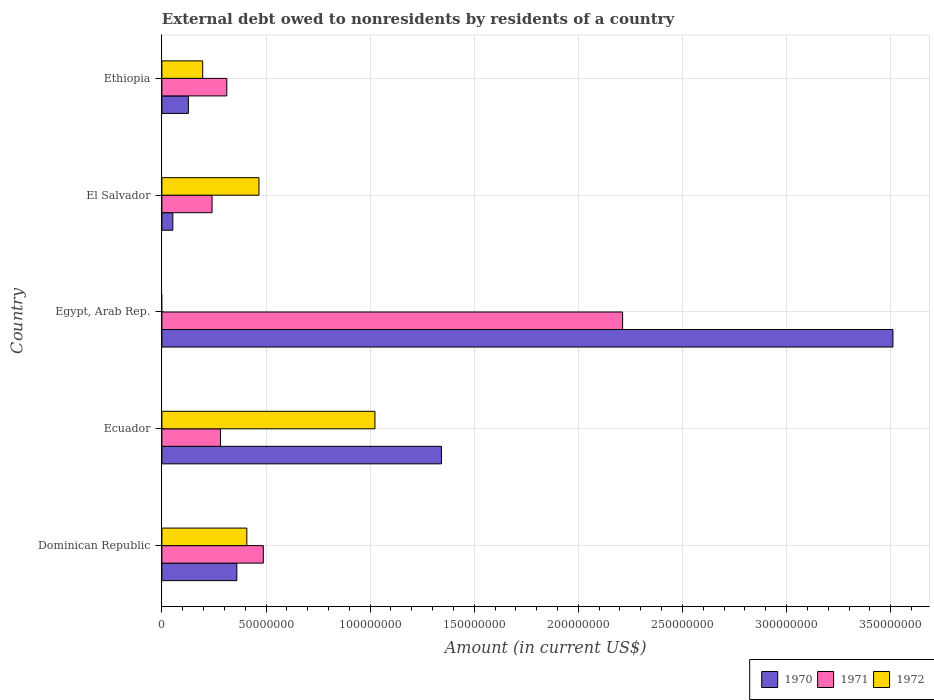Are the number of bars on each tick of the Y-axis equal?
Make the answer very short. No. What is the label of the 2nd group of bars from the top?
Provide a succinct answer. El Salvador. In how many cases, is the number of bars for a given country not equal to the number of legend labels?
Your answer should be very brief. 1. What is the external debt owed by residents in 1972 in Egypt, Arab Rep.?
Keep it short and to the point. 0. Across all countries, what is the maximum external debt owed by residents in 1971?
Your answer should be compact. 2.21e+08. Across all countries, what is the minimum external debt owed by residents in 1971?
Your answer should be very brief. 2.41e+07. In which country was the external debt owed by residents in 1971 maximum?
Your answer should be very brief. Egypt, Arab Rep. What is the total external debt owed by residents in 1970 in the graph?
Give a very brief answer. 5.39e+08. What is the difference between the external debt owed by residents in 1970 in Dominican Republic and that in El Salvador?
Offer a terse response. 3.07e+07. What is the difference between the external debt owed by residents in 1972 in El Salvador and the external debt owed by residents in 1970 in Dominican Republic?
Provide a short and direct response. 1.06e+07. What is the average external debt owed by residents in 1971 per country?
Your response must be concise. 7.07e+07. What is the difference between the external debt owed by residents in 1970 and external debt owed by residents in 1972 in El Salvador?
Provide a short and direct response. -4.14e+07. What is the ratio of the external debt owed by residents in 1972 in Dominican Republic to that in El Salvador?
Give a very brief answer. 0.88. Is the external debt owed by residents in 1970 in Egypt, Arab Rep. less than that in Ethiopia?
Provide a short and direct response. No. What is the difference between the highest and the second highest external debt owed by residents in 1970?
Make the answer very short. 2.17e+08. What is the difference between the highest and the lowest external debt owed by residents in 1972?
Offer a very short reply. 1.02e+08. In how many countries, is the external debt owed by residents in 1971 greater than the average external debt owed by residents in 1971 taken over all countries?
Ensure brevity in your answer.  1. Is the sum of the external debt owed by residents in 1971 in Dominican Republic and El Salvador greater than the maximum external debt owed by residents in 1972 across all countries?
Your answer should be compact. No. Is it the case that in every country, the sum of the external debt owed by residents in 1972 and external debt owed by residents in 1970 is greater than the external debt owed by residents in 1971?
Your answer should be very brief. Yes. How many countries are there in the graph?
Your answer should be very brief. 5. What is the difference between two consecutive major ticks on the X-axis?
Offer a terse response. 5.00e+07. Does the graph contain any zero values?
Provide a short and direct response. Yes. Does the graph contain grids?
Your answer should be compact. Yes. Where does the legend appear in the graph?
Your answer should be compact. Bottom right. What is the title of the graph?
Your answer should be very brief. External debt owed to nonresidents by residents of a country. What is the label or title of the X-axis?
Keep it short and to the point. Amount (in current US$). What is the label or title of the Y-axis?
Provide a succinct answer. Country. What is the Amount (in current US$) in 1970 in Dominican Republic?
Offer a very short reply. 3.60e+07. What is the Amount (in current US$) in 1971 in Dominican Republic?
Offer a very short reply. 4.87e+07. What is the Amount (in current US$) in 1972 in Dominican Republic?
Keep it short and to the point. 4.08e+07. What is the Amount (in current US$) in 1970 in Ecuador?
Ensure brevity in your answer.  1.34e+08. What is the Amount (in current US$) in 1971 in Ecuador?
Offer a terse response. 2.81e+07. What is the Amount (in current US$) of 1972 in Ecuador?
Offer a very short reply. 1.02e+08. What is the Amount (in current US$) in 1970 in Egypt, Arab Rep.?
Make the answer very short. 3.51e+08. What is the Amount (in current US$) in 1971 in Egypt, Arab Rep.?
Your answer should be very brief. 2.21e+08. What is the Amount (in current US$) in 1970 in El Salvador?
Your answer should be very brief. 5.25e+06. What is the Amount (in current US$) in 1971 in El Salvador?
Provide a short and direct response. 2.41e+07. What is the Amount (in current US$) of 1972 in El Salvador?
Provide a short and direct response. 4.66e+07. What is the Amount (in current US$) in 1970 in Ethiopia?
Your response must be concise. 1.27e+07. What is the Amount (in current US$) of 1971 in Ethiopia?
Give a very brief answer. 3.12e+07. What is the Amount (in current US$) of 1972 in Ethiopia?
Make the answer very short. 1.96e+07. Across all countries, what is the maximum Amount (in current US$) in 1970?
Your response must be concise. 3.51e+08. Across all countries, what is the maximum Amount (in current US$) in 1971?
Ensure brevity in your answer.  2.21e+08. Across all countries, what is the maximum Amount (in current US$) in 1972?
Provide a short and direct response. 1.02e+08. Across all countries, what is the minimum Amount (in current US$) in 1970?
Keep it short and to the point. 5.25e+06. Across all countries, what is the minimum Amount (in current US$) in 1971?
Make the answer very short. 2.41e+07. Across all countries, what is the minimum Amount (in current US$) of 1972?
Provide a short and direct response. 0. What is the total Amount (in current US$) in 1970 in the graph?
Your response must be concise. 5.39e+08. What is the total Amount (in current US$) of 1971 in the graph?
Give a very brief answer. 3.53e+08. What is the total Amount (in current US$) of 1972 in the graph?
Ensure brevity in your answer.  2.09e+08. What is the difference between the Amount (in current US$) of 1970 in Dominican Republic and that in Ecuador?
Give a very brief answer. -9.83e+07. What is the difference between the Amount (in current US$) of 1971 in Dominican Republic and that in Ecuador?
Ensure brevity in your answer.  2.06e+07. What is the difference between the Amount (in current US$) in 1972 in Dominican Republic and that in Ecuador?
Provide a short and direct response. -6.15e+07. What is the difference between the Amount (in current US$) of 1970 in Dominican Republic and that in Egypt, Arab Rep.?
Keep it short and to the point. -3.15e+08. What is the difference between the Amount (in current US$) in 1971 in Dominican Republic and that in Egypt, Arab Rep.?
Make the answer very short. -1.73e+08. What is the difference between the Amount (in current US$) in 1970 in Dominican Republic and that in El Salvador?
Provide a succinct answer. 3.07e+07. What is the difference between the Amount (in current US$) of 1971 in Dominican Republic and that in El Salvador?
Keep it short and to the point. 2.46e+07. What is the difference between the Amount (in current US$) of 1972 in Dominican Republic and that in El Salvador?
Make the answer very short. -5.82e+06. What is the difference between the Amount (in current US$) in 1970 in Dominican Republic and that in Ethiopia?
Offer a terse response. 2.33e+07. What is the difference between the Amount (in current US$) in 1971 in Dominican Republic and that in Ethiopia?
Give a very brief answer. 1.75e+07. What is the difference between the Amount (in current US$) in 1972 in Dominican Republic and that in Ethiopia?
Your answer should be very brief. 2.12e+07. What is the difference between the Amount (in current US$) of 1970 in Ecuador and that in Egypt, Arab Rep.?
Your response must be concise. -2.17e+08. What is the difference between the Amount (in current US$) in 1971 in Ecuador and that in Egypt, Arab Rep.?
Your answer should be compact. -1.93e+08. What is the difference between the Amount (in current US$) in 1970 in Ecuador and that in El Salvador?
Offer a terse response. 1.29e+08. What is the difference between the Amount (in current US$) in 1971 in Ecuador and that in El Salvador?
Offer a terse response. 4.01e+06. What is the difference between the Amount (in current US$) in 1972 in Ecuador and that in El Salvador?
Ensure brevity in your answer.  5.57e+07. What is the difference between the Amount (in current US$) of 1970 in Ecuador and that in Ethiopia?
Offer a terse response. 1.22e+08. What is the difference between the Amount (in current US$) in 1971 in Ecuador and that in Ethiopia?
Your answer should be very brief. -3.06e+06. What is the difference between the Amount (in current US$) of 1972 in Ecuador and that in Ethiopia?
Keep it short and to the point. 8.27e+07. What is the difference between the Amount (in current US$) of 1970 in Egypt, Arab Rep. and that in El Salvador?
Provide a succinct answer. 3.46e+08. What is the difference between the Amount (in current US$) of 1971 in Egypt, Arab Rep. and that in El Salvador?
Offer a terse response. 1.97e+08. What is the difference between the Amount (in current US$) in 1970 in Egypt, Arab Rep. and that in Ethiopia?
Make the answer very short. 3.38e+08. What is the difference between the Amount (in current US$) of 1971 in Egypt, Arab Rep. and that in Ethiopia?
Ensure brevity in your answer.  1.90e+08. What is the difference between the Amount (in current US$) in 1970 in El Salvador and that in Ethiopia?
Your answer should be compact. -7.48e+06. What is the difference between the Amount (in current US$) of 1971 in El Salvador and that in Ethiopia?
Keep it short and to the point. -7.07e+06. What is the difference between the Amount (in current US$) of 1972 in El Salvador and that in Ethiopia?
Provide a succinct answer. 2.70e+07. What is the difference between the Amount (in current US$) of 1970 in Dominican Republic and the Amount (in current US$) of 1971 in Ecuador?
Make the answer very short. 7.88e+06. What is the difference between the Amount (in current US$) in 1970 in Dominican Republic and the Amount (in current US$) in 1972 in Ecuador?
Offer a very short reply. -6.63e+07. What is the difference between the Amount (in current US$) of 1971 in Dominican Republic and the Amount (in current US$) of 1972 in Ecuador?
Your answer should be very brief. -5.36e+07. What is the difference between the Amount (in current US$) in 1970 in Dominican Republic and the Amount (in current US$) in 1971 in Egypt, Arab Rep.?
Give a very brief answer. -1.85e+08. What is the difference between the Amount (in current US$) of 1970 in Dominican Republic and the Amount (in current US$) of 1971 in El Salvador?
Your answer should be compact. 1.19e+07. What is the difference between the Amount (in current US$) of 1970 in Dominican Republic and the Amount (in current US$) of 1972 in El Salvador?
Ensure brevity in your answer.  -1.06e+07. What is the difference between the Amount (in current US$) in 1971 in Dominican Republic and the Amount (in current US$) in 1972 in El Salvador?
Offer a terse response. 2.10e+06. What is the difference between the Amount (in current US$) in 1970 in Dominican Republic and the Amount (in current US$) in 1971 in Ethiopia?
Keep it short and to the point. 4.81e+06. What is the difference between the Amount (in current US$) of 1970 in Dominican Republic and the Amount (in current US$) of 1972 in Ethiopia?
Your response must be concise. 1.64e+07. What is the difference between the Amount (in current US$) in 1971 in Dominican Republic and the Amount (in current US$) in 1972 in Ethiopia?
Your answer should be very brief. 2.91e+07. What is the difference between the Amount (in current US$) in 1970 in Ecuador and the Amount (in current US$) in 1971 in Egypt, Arab Rep.?
Provide a succinct answer. -8.70e+07. What is the difference between the Amount (in current US$) of 1970 in Ecuador and the Amount (in current US$) of 1971 in El Salvador?
Provide a short and direct response. 1.10e+08. What is the difference between the Amount (in current US$) of 1970 in Ecuador and the Amount (in current US$) of 1972 in El Salvador?
Your answer should be very brief. 8.76e+07. What is the difference between the Amount (in current US$) of 1971 in Ecuador and the Amount (in current US$) of 1972 in El Salvador?
Offer a very short reply. -1.85e+07. What is the difference between the Amount (in current US$) of 1970 in Ecuador and the Amount (in current US$) of 1971 in Ethiopia?
Your response must be concise. 1.03e+08. What is the difference between the Amount (in current US$) in 1970 in Ecuador and the Amount (in current US$) in 1972 in Ethiopia?
Offer a terse response. 1.15e+08. What is the difference between the Amount (in current US$) in 1971 in Ecuador and the Amount (in current US$) in 1972 in Ethiopia?
Make the answer very short. 8.52e+06. What is the difference between the Amount (in current US$) of 1970 in Egypt, Arab Rep. and the Amount (in current US$) of 1971 in El Salvador?
Ensure brevity in your answer.  3.27e+08. What is the difference between the Amount (in current US$) of 1970 in Egypt, Arab Rep. and the Amount (in current US$) of 1972 in El Salvador?
Give a very brief answer. 3.04e+08. What is the difference between the Amount (in current US$) of 1971 in Egypt, Arab Rep. and the Amount (in current US$) of 1972 in El Salvador?
Offer a terse response. 1.75e+08. What is the difference between the Amount (in current US$) in 1970 in Egypt, Arab Rep. and the Amount (in current US$) in 1971 in Ethiopia?
Offer a very short reply. 3.20e+08. What is the difference between the Amount (in current US$) of 1970 in Egypt, Arab Rep. and the Amount (in current US$) of 1972 in Ethiopia?
Your response must be concise. 3.31e+08. What is the difference between the Amount (in current US$) of 1971 in Egypt, Arab Rep. and the Amount (in current US$) of 1972 in Ethiopia?
Keep it short and to the point. 2.02e+08. What is the difference between the Amount (in current US$) in 1970 in El Salvador and the Amount (in current US$) in 1971 in Ethiopia?
Offer a terse response. -2.59e+07. What is the difference between the Amount (in current US$) in 1970 in El Salvador and the Amount (in current US$) in 1972 in Ethiopia?
Offer a terse response. -1.44e+07. What is the difference between the Amount (in current US$) in 1971 in El Salvador and the Amount (in current US$) in 1972 in Ethiopia?
Provide a short and direct response. 4.50e+06. What is the average Amount (in current US$) in 1970 per country?
Your response must be concise. 1.08e+08. What is the average Amount (in current US$) in 1971 per country?
Offer a terse response. 7.07e+07. What is the average Amount (in current US$) in 1972 per country?
Keep it short and to the point. 4.19e+07. What is the difference between the Amount (in current US$) of 1970 and Amount (in current US$) of 1971 in Dominican Republic?
Your response must be concise. -1.27e+07. What is the difference between the Amount (in current US$) of 1970 and Amount (in current US$) of 1972 in Dominican Republic?
Offer a very short reply. -4.81e+06. What is the difference between the Amount (in current US$) of 1971 and Amount (in current US$) of 1972 in Dominican Republic?
Make the answer very short. 7.91e+06. What is the difference between the Amount (in current US$) in 1970 and Amount (in current US$) in 1971 in Ecuador?
Offer a very short reply. 1.06e+08. What is the difference between the Amount (in current US$) of 1970 and Amount (in current US$) of 1972 in Ecuador?
Provide a short and direct response. 3.19e+07. What is the difference between the Amount (in current US$) in 1971 and Amount (in current US$) in 1972 in Ecuador?
Offer a very short reply. -7.42e+07. What is the difference between the Amount (in current US$) in 1970 and Amount (in current US$) in 1971 in Egypt, Arab Rep.?
Give a very brief answer. 1.30e+08. What is the difference between the Amount (in current US$) of 1970 and Amount (in current US$) of 1971 in El Salvador?
Provide a short and direct response. -1.89e+07. What is the difference between the Amount (in current US$) of 1970 and Amount (in current US$) of 1972 in El Salvador?
Provide a succinct answer. -4.14e+07. What is the difference between the Amount (in current US$) of 1971 and Amount (in current US$) of 1972 in El Salvador?
Provide a short and direct response. -2.25e+07. What is the difference between the Amount (in current US$) of 1970 and Amount (in current US$) of 1971 in Ethiopia?
Provide a succinct answer. -1.84e+07. What is the difference between the Amount (in current US$) in 1970 and Amount (in current US$) in 1972 in Ethiopia?
Give a very brief answer. -6.87e+06. What is the difference between the Amount (in current US$) in 1971 and Amount (in current US$) in 1972 in Ethiopia?
Provide a short and direct response. 1.16e+07. What is the ratio of the Amount (in current US$) of 1970 in Dominican Republic to that in Ecuador?
Give a very brief answer. 0.27. What is the ratio of the Amount (in current US$) in 1971 in Dominican Republic to that in Ecuador?
Keep it short and to the point. 1.73. What is the ratio of the Amount (in current US$) of 1972 in Dominican Republic to that in Ecuador?
Keep it short and to the point. 0.4. What is the ratio of the Amount (in current US$) of 1970 in Dominican Republic to that in Egypt, Arab Rep.?
Your answer should be very brief. 0.1. What is the ratio of the Amount (in current US$) of 1971 in Dominican Republic to that in Egypt, Arab Rep.?
Offer a terse response. 0.22. What is the ratio of the Amount (in current US$) in 1970 in Dominican Republic to that in El Salvador?
Ensure brevity in your answer.  6.86. What is the ratio of the Amount (in current US$) in 1971 in Dominican Republic to that in El Salvador?
Provide a succinct answer. 2.02. What is the ratio of the Amount (in current US$) of 1972 in Dominican Republic to that in El Salvador?
Your answer should be very brief. 0.88. What is the ratio of the Amount (in current US$) in 1970 in Dominican Republic to that in Ethiopia?
Ensure brevity in your answer.  2.83. What is the ratio of the Amount (in current US$) in 1971 in Dominican Republic to that in Ethiopia?
Provide a short and direct response. 1.56. What is the ratio of the Amount (in current US$) of 1972 in Dominican Republic to that in Ethiopia?
Your answer should be compact. 2.08. What is the ratio of the Amount (in current US$) in 1970 in Ecuador to that in Egypt, Arab Rep.?
Provide a short and direct response. 0.38. What is the ratio of the Amount (in current US$) of 1971 in Ecuador to that in Egypt, Arab Rep.?
Provide a short and direct response. 0.13. What is the ratio of the Amount (in current US$) of 1970 in Ecuador to that in El Salvador?
Provide a succinct answer. 25.59. What is the ratio of the Amount (in current US$) of 1971 in Ecuador to that in El Salvador?
Offer a terse response. 1.17. What is the ratio of the Amount (in current US$) in 1972 in Ecuador to that in El Salvador?
Provide a succinct answer. 2.2. What is the ratio of the Amount (in current US$) of 1970 in Ecuador to that in Ethiopia?
Provide a short and direct response. 10.55. What is the ratio of the Amount (in current US$) of 1971 in Ecuador to that in Ethiopia?
Ensure brevity in your answer.  0.9. What is the ratio of the Amount (in current US$) of 1972 in Ecuador to that in Ethiopia?
Your answer should be very brief. 5.22. What is the ratio of the Amount (in current US$) in 1970 in Egypt, Arab Rep. to that in El Salvador?
Your answer should be very brief. 66.92. What is the ratio of the Amount (in current US$) in 1971 in Egypt, Arab Rep. to that in El Salvador?
Offer a very short reply. 9.18. What is the ratio of the Amount (in current US$) in 1970 in Egypt, Arab Rep. to that in Ethiopia?
Offer a terse response. 27.59. What is the ratio of the Amount (in current US$) in 1971 in Egypt, Arab Rep. to that in Ethiopia?
Give a very brief answer. 7.1. What is the ratio of the Amount (in current US$) in 1970 in El Salvador to that in Ethiopia?
Your response must be concise. 0.41. What is the ratio of the Amount (in current US$) of 1971 in El Salvador to that in Ethiopia?
Provide a short and direct response. 0.77. What is the ratio of the Amount (in current US$) in 1972 in El Salvador to that in Ethiopia?
Make the answer very short. 2.38. What is the difference between the highest and the second highest Amount (in current US$) in 1970?
Offer a terse response. 2.17e+08. What is the difference between the highest and the second highest Amount (in current US$) in 1971?
Give a very brief answer. 1.73e+08. What is the difference between the highest and the second highest Amount (in current US$) of 1972?
Offer a very short reply. 5.57e+07. What is the difference between the highest and the lowest Amount (in current US$) of 1970?
Provide a succinct answer. 3.46e+08. What is the difference between the highest and the lowest Amount (in current US$) of 1971?
Your answer should be compact. 1.97e+08. What is the difference between the highest and the lowest Amount (in current US$) in 1972?
Offer a terse response. 1.02e+08. 